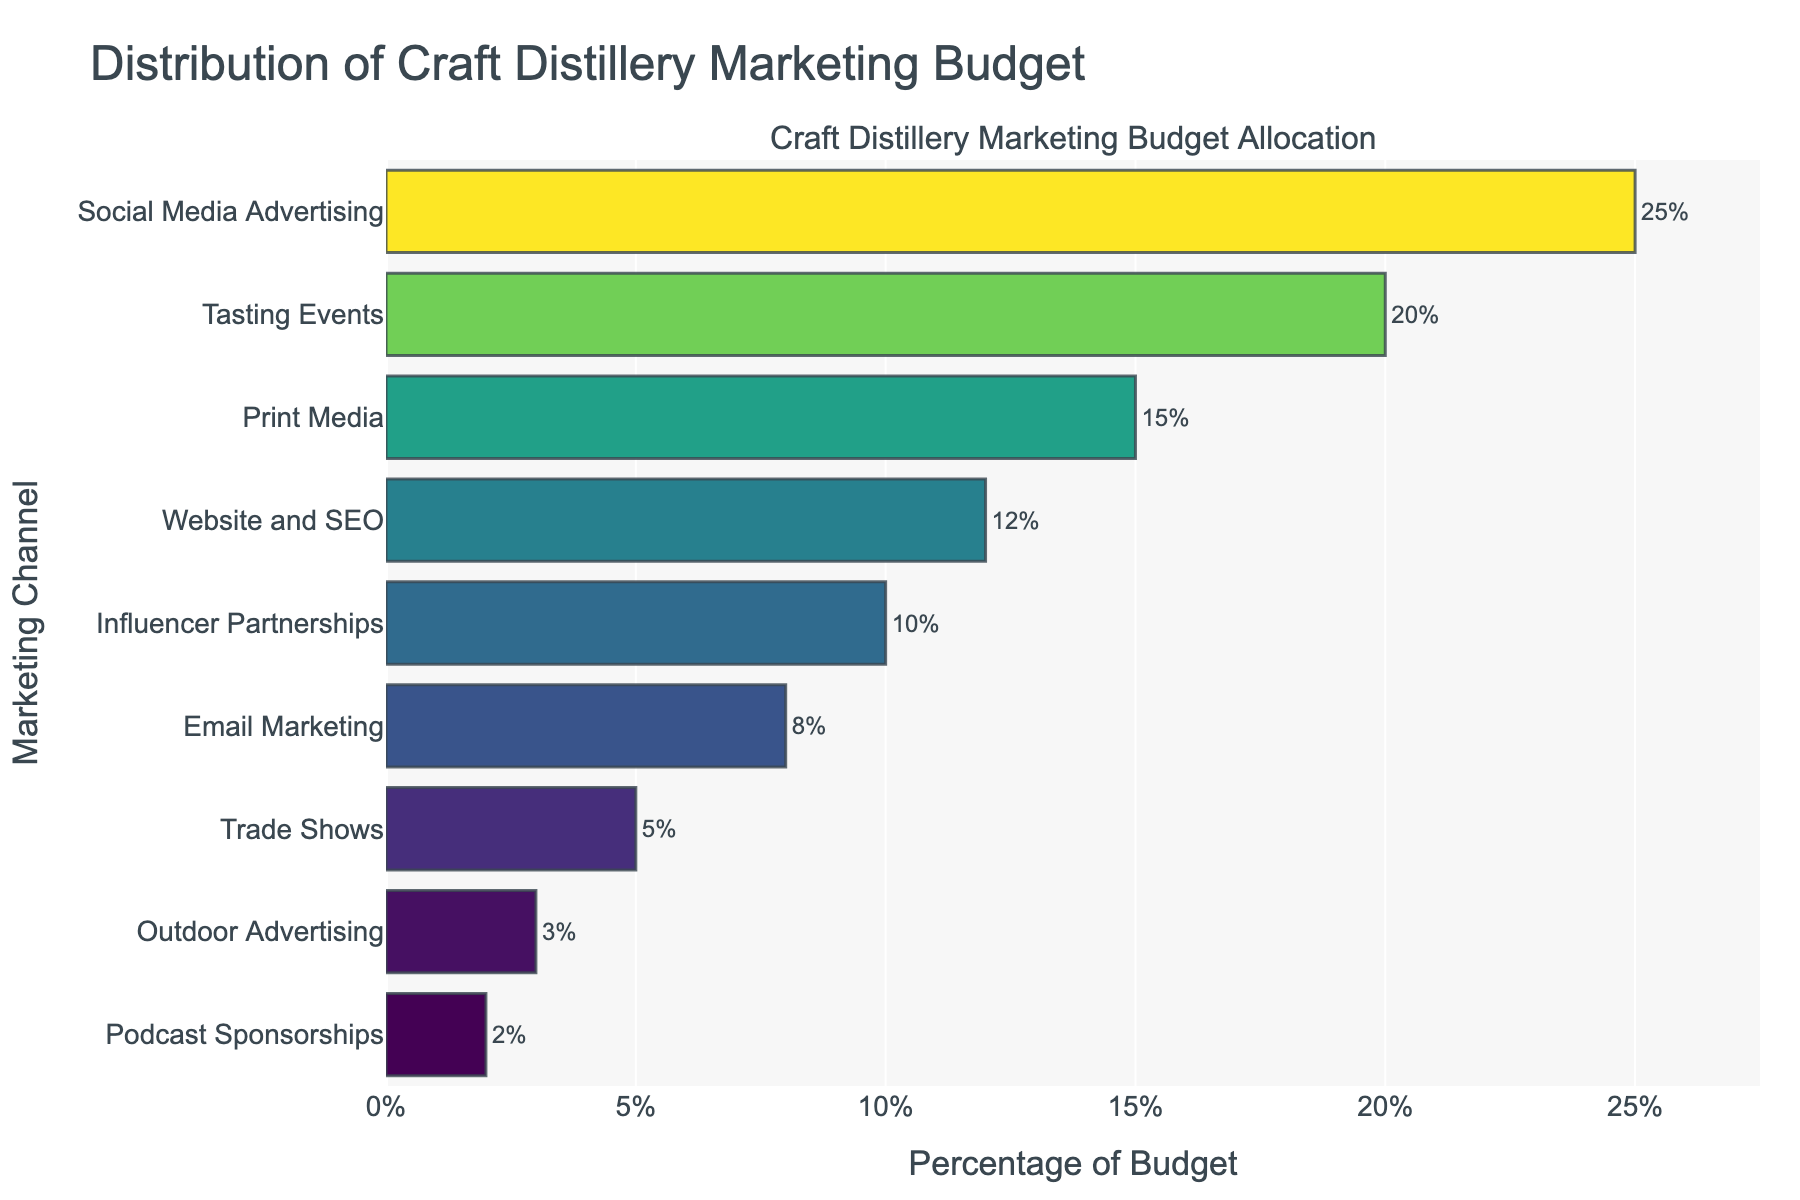Which channel receives the largest portion of the marketing budget? To determine which channel receives the largest portion, look for the bar with the greatest length. The bar for Social Media Advertising is the longest.
Answer: Social Media Advertising Which two marketing channels have less than 5% of the budget allocation each? Identify the bars that have their percentages labeled as less than 5%. The bars for Outdoor Advertising (3%) and Podcast Sponsorships (2%) are the only ones below 5%.
Answer: Outdoor Advertising and Podcast Sponsorships What is the combined budget allocation for Tasting Events and Trade Shows? Sum the percentages of Tasting Events and Trade Shows. Tasting Events have 20% and Trade Shows have 5%, so the total is 20% + 5%.
Answer: 25% Is the budget allocation for Email Marketing greater than that for Influencer Partnerships? Compare the lengths of the bars for Email Marketing and Influencer Partnerships. Email Marketing has 8%, while Influencer Partnerships have 10%.
Answer: No What is the difference in percentage between the highest and lowest budget allocations? Subtract the percentage of the channel with the lowest allocation from the percentage of the channel with the highest allocation. Social Media Advertising has 25%, while Podcast Sponsorships have 2%, resulting in 25% - 2%.
Answer: 23% Which channel has the smallest portion of the marketing budget? Look for the bar with the smallest percentage value. The smallest bar is for Podcast Sponsorships with 2%.
Answer: Podcast Sponsorships Which channel has a budget allocation closest to 15%? Identify the bar with a percentage closest to 15%. The channel with exactly 15% allocation is Print Media.
Answer: Print Media What is the average budget allocation across all channels? Sum up all the percentage values and divide by the number of channels. (25 + 20 + 15 + 12 + 10 + 8 + 5 + 3 + 2) / 9 = 100 / 9.
Answer: Approximately 11.11% Rank the top three channels in terms of budget allocation. Identify the three longest bars and order them. The top three are Social Media Advertising (25%), Tasting Events (20%), and Print Media (15%).
Answer: Social Media Advertising, Tasting Events, Print Media How much more budget is allocated to Website and SEO compared to Outdoor Advertising? Subtract the percentage of Outdoor Advertising from Website and SEO. Website and SEO have 12%, and Outdoor Advertising has 3%. 12% - 3% = 9%.
Answer: 9% 